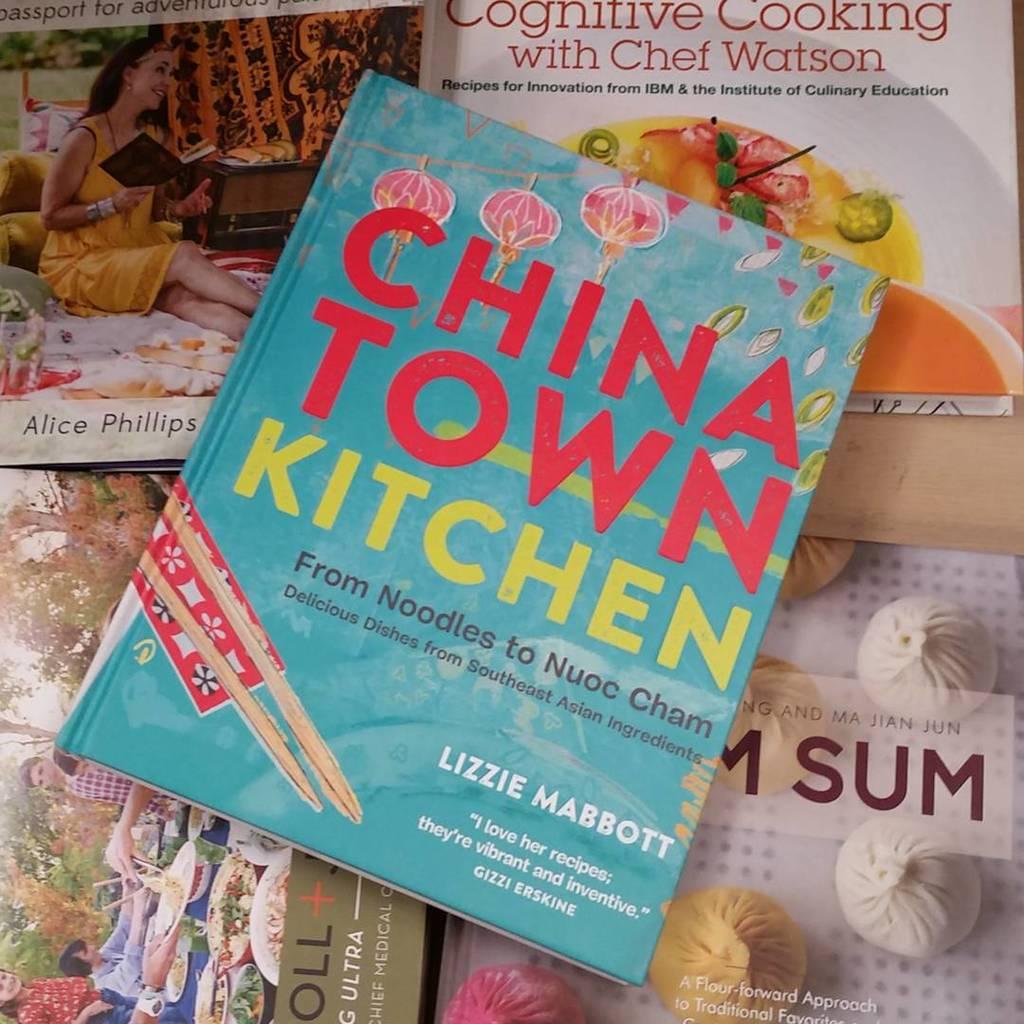<image>
Describe the image concisely. A blue color cover for the china town kitchen book. 